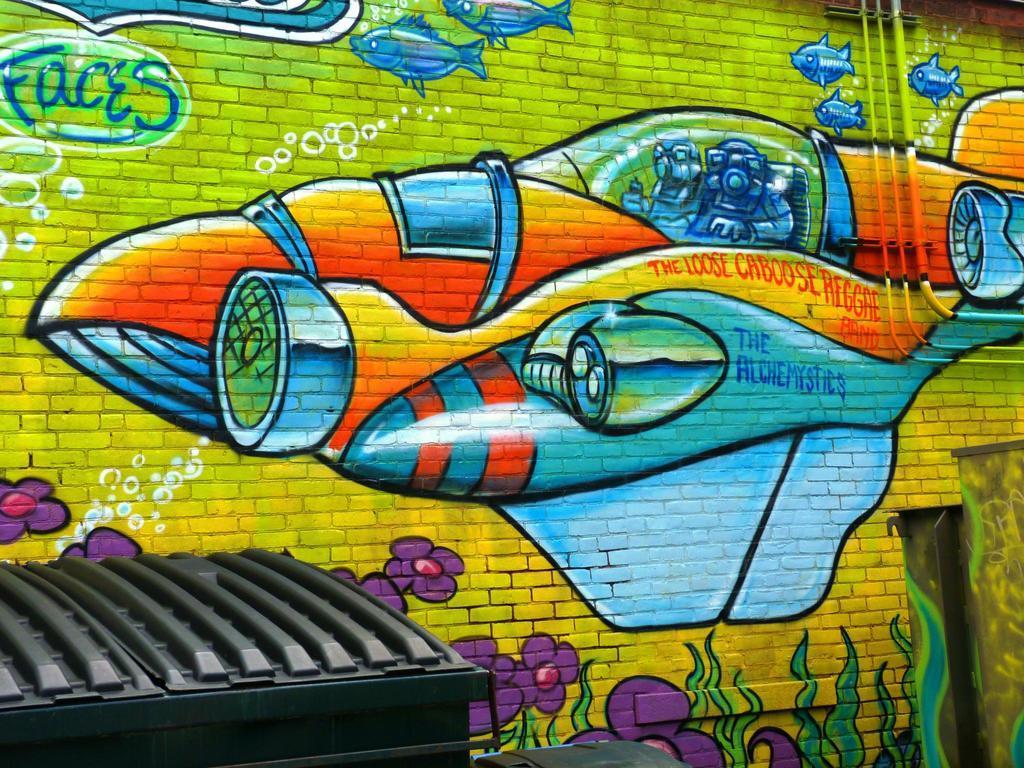In one or two sentences, can you explain what this image depicts? In this image, we can see a painting of some people on the plane and there is some text, some plants with flowers and we can see fish and bubbles on the wall. At the bottom, we can see some other objects. 